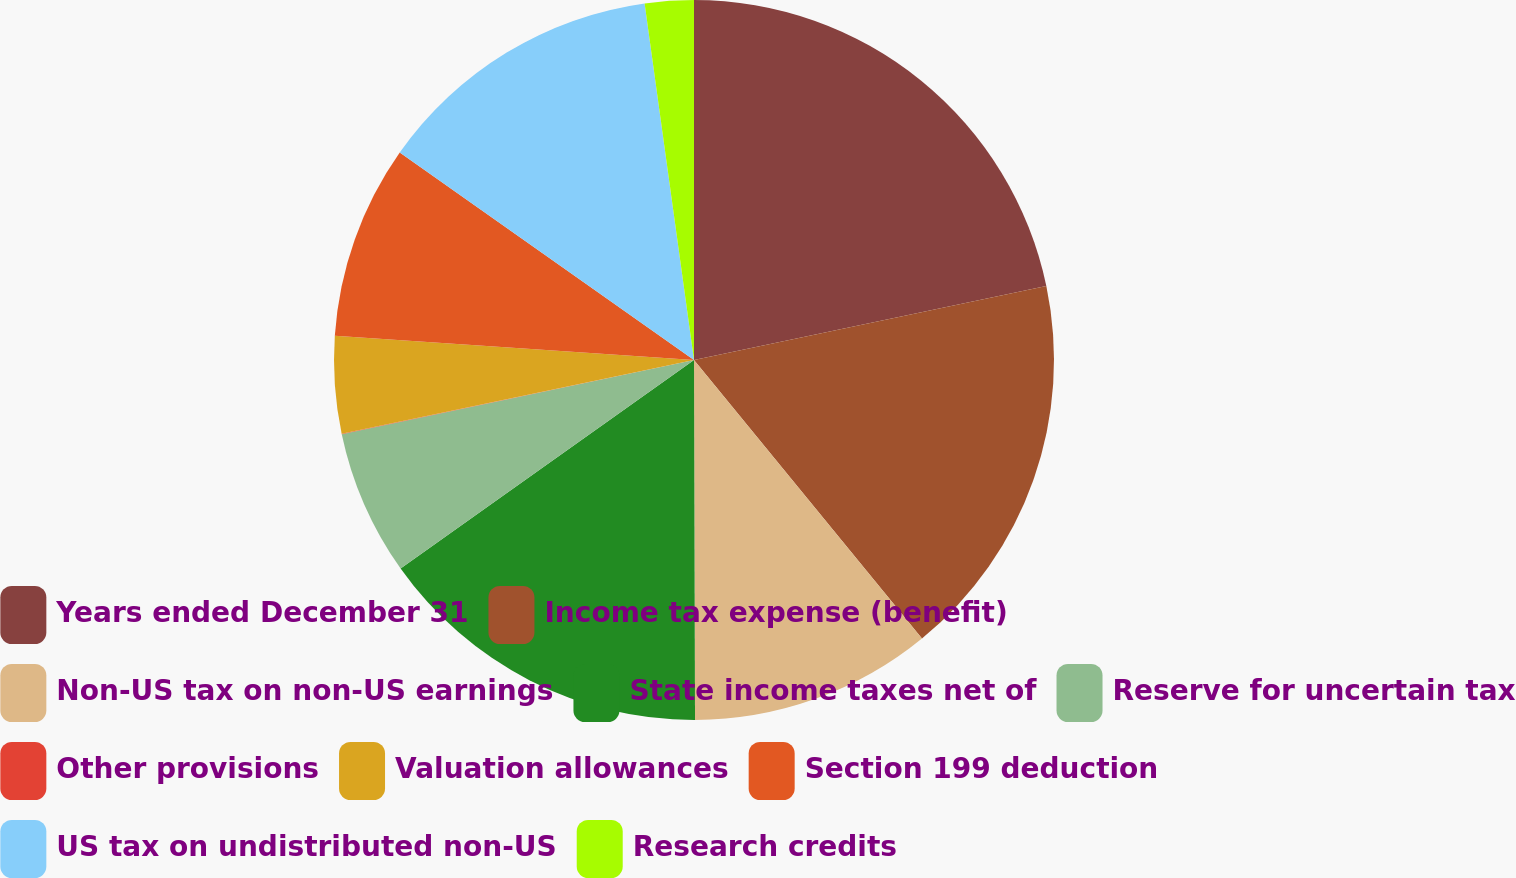<chart> <loc_0><loc_0><loc_500><loc_500><pie_chart><fcel>Years ended December 31<fcel>Income tax expense (benefit)<fcel>Non-US tax on non-US earnings<fcel>State income taxes net of<fcel>Reserve for uncertain tax<fcel>Other provisions<fcel>Valuation allowances<fcel>Section 199 deduction<fcel>US tax on undistributed non-US<fcel>Research credits<nl><fcel>21.71%<fcel>17.38%<fcel>10.87%<fcel>15.21%<fcel>6.53%<fcel>0.02%<fcel>4.36%<fcel>8.7%<fcel>13.04%<fcel>2.19%<nl></chart> 